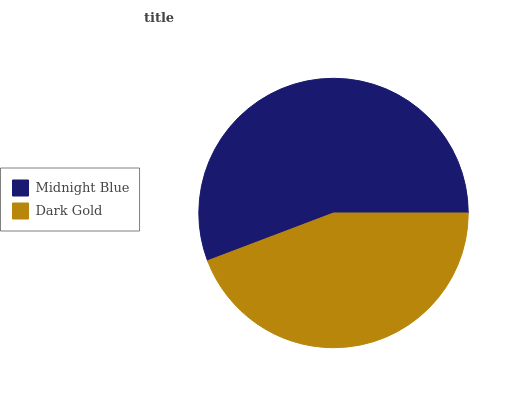Is Dark Gold the minimum?
Answer yes or no. Yes. Is Midnight Blue the maximum?
Answer yes or no. Yes. Is Dark Gold the maximum?
Answer yes or no. No. Is Midnight Blue greater than Dark Gold?
Answer yes or no. Yes. Is Dark Gold less than Midnight Blue?
Answer yes or no. Yes. Is Dark Gold greater than Midnight Blue?
Answer yes or no. No. Is Midnight Blue less than Dark Gold?
Answer yes or no. No. Is Midnight Blue the high median?
Answer yes or no. Yes. Is Dark Gold the low median?
Answer yes or no. Yes. Is Dark Gold the high median?
Answer yes or no. No. Is Midnight Blue the low median?
Answer yes or no. No. 